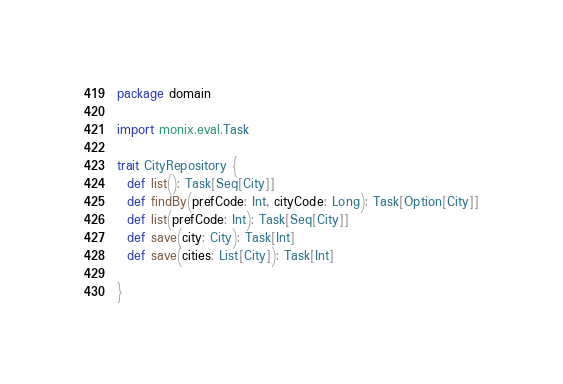<code> <loc_0><loc_0><loc_500><loc_500><_Scala_>package domain

import monix.eval.Task

trait CityRepository {
  def list(): Task[Seq[City]]
  def findBy(prefCode: Int, cityCode: Long): Task[Option[City]]
  def list(prefCode: Int): Task[Seq[City]]
  def save(city: City): Task[Int]
  def save(cities: List[City]): Task[Int]

}
</code> 